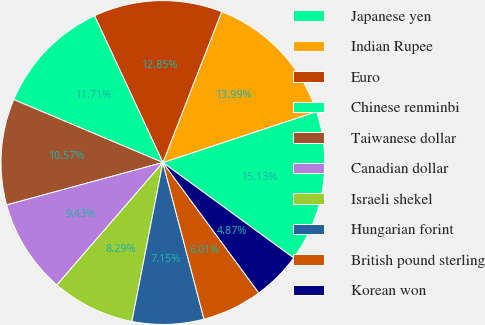<chart> <loc_0><loc_0><loc_500><loc_500><pie_chart><fcel>Japanese yen<fcel>Indian Rupee<fcel>Euro<fcel>Chinese renminbi<fcel>Taiwanese dollar<fcel>Canadian dollar<fcel>Israeli shekel<fcel>Hungarian forint<fcel>British pound sterling<fcel>Korean won<nl><fcel>15.13%<fcel>13.99%<fcel>12.85%<fcel>11.71%<fcel>10.57%<fcel>9.43%<fcel>8.29%<fcel>7.15%<fcel>6.01%<fcel>4.87%<nl></chart> 